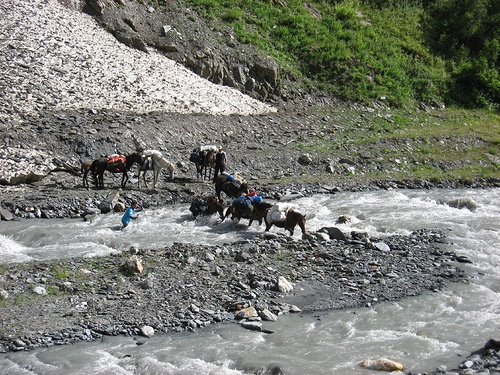Describe the objects in this image and their specific colors. I can see horse in darkgray, black, gray, and maroon tones, horse in darkgray, black, gray, and white tones, horse in darkgray, gray, black, and lightgray tones, horse in darkgray, black, gray, and navy tones, and horse in darkgray, black, gray, and lightgray tones in this image. 